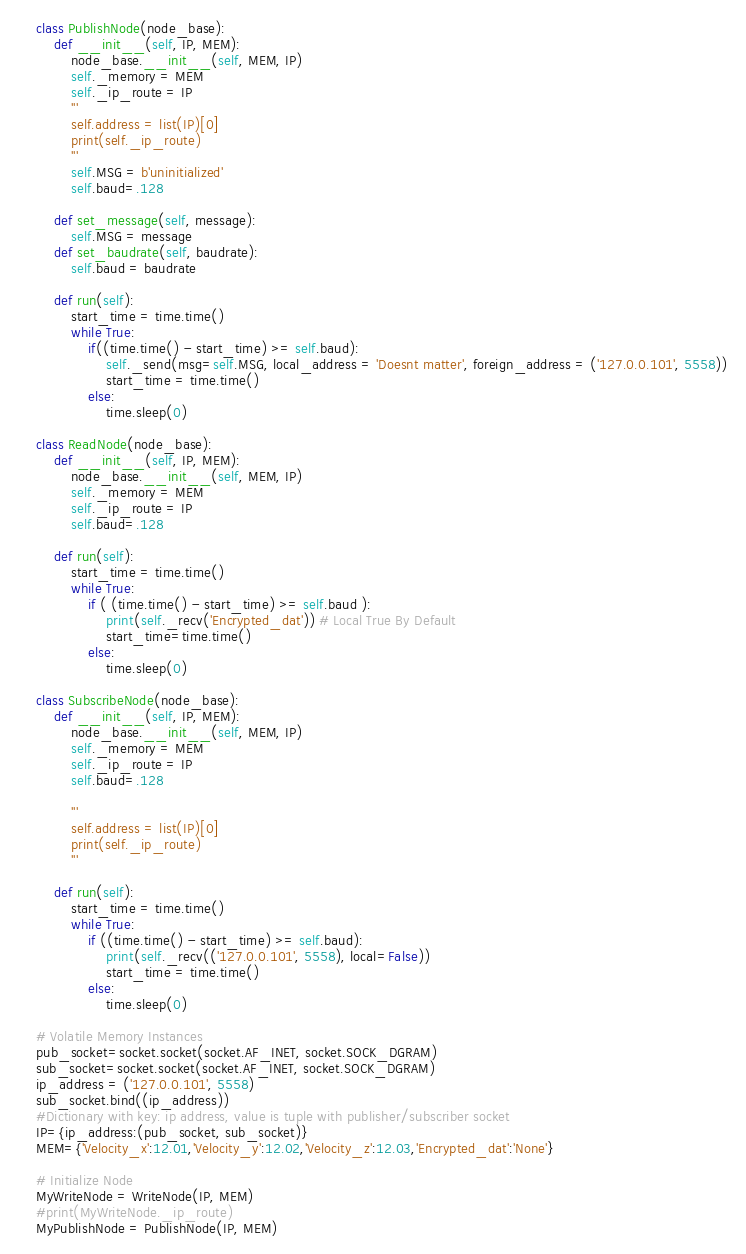<code> <loc_0><loc_0><loc_500><loc_500><_Python_>    class PublishNode(node_base):
        def __init__(self, IP, MEM):
            node_base.__init__(self, MEM, IP)
            self._memory = MEM
            self._ip_route = IP
            '''
            self.address = list(IP)[0]
            print(self._ip_route)
            '''
            self.MSG = b'uninitialized'
            self.baud=.128

        def set_message(self, message):
            self.MSG = message
        def set_baudrate(self, baudrate):
            self.baud = baudrate

        def run(self):
            start_time = time.time()
            while True:
                if((time.time() - start_time) >= self.baud):
                    self._send(msg=self.MSG, local_address = 'Doesnt matter', foreign_address = ('127.0.0.101', 5558))
                    start_time = time.time()
                else:
                    time.sleep(0)

    class ReadNode(node_base):
        def __init__(self, IP, MEM):
            node_base.__init__(self, MEM, IP)
            self._memory = MEM
            self._ip_route = IP
            self.baud=.128

        def run(self):
            start_time = time.time()
            while True:
                if ( (time.time() - start_time) >= self.baud ):
                    print(self._recv('Encrypted_dat')) # Local True By Default
                    start_time=time.time()
                else:
                    time.sleep(0)

    class SubscribeNode(node_base):
        def __init__(self, IP, MEM):
            node_base.__init__(self, MEM, IP)
            self._memory = MEM
            self._ip_route = IP
            self.baud=.128

            '''
            self.address = list(IP)[0]
            print(self._ip_route)
            '''

        def run(self):
            start_time = time.time()
            while True:
                if ((time.time() - start_time) >= self.baud):
                    print(self._recv(('127.0.0.101', 5558), local=False))
                    start_time = time.time()
                else:
                    time.sleep(0)

    # Volatile Memory Instances
    pub_socket=socket.socket(socket.AF_INET, socket.SOCK_DGRAM)
    sub_socket=socket.socket(socket.AF_INET, socket.SOCK_DGRAM)
    ip_address = ('127.0.0.101', 5558)
    sub_socket.bind((ip_address))
    #Dictionary with key: ip address, value is tuple with publisher/subscriber socket
    IP={ip_address:(pub_socket, sub_socket)}
    MEM={'Velocity_x':12.01,'Velocity_y':12.02,'Velocity_z':12.03,'Encrypted_dat':'None'}

    # Initialize Node
    MyWriteNode = WriteNode(IP, MEM)
    #print(MyWriteNode._ip_route)
    MyPublishNode = PublishNode(IP, MEM)</code> 